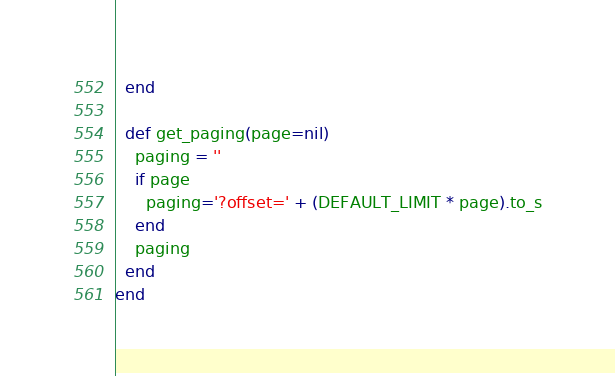Convert code to text. <code><loc_0><loc_0><loc_500><loc_500><_Ruby_>  end

  def get_paging(page=nil)
    paging = ''
    if page
      paging='?offset=' + (DEFAULT_LIMIT * page).to_s
    end
    paging
  end
end
</code> 